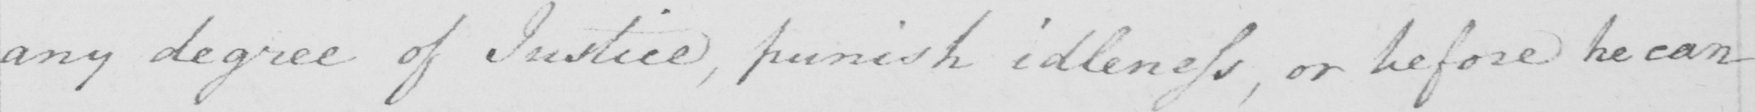Can you tell me what this handwritten text says? any degree of Justice , punish idleness , or before he can 